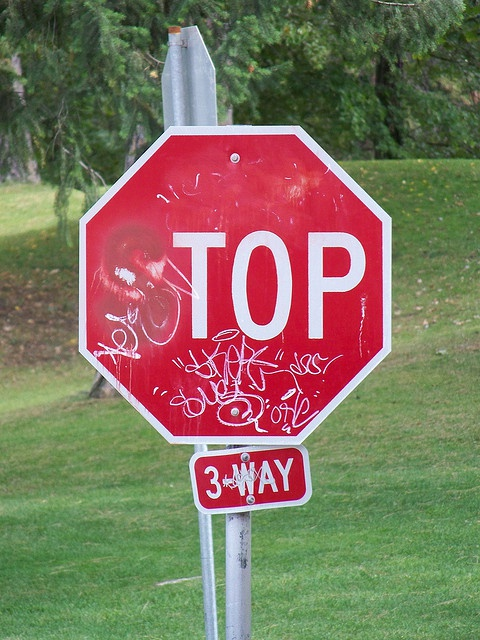Describe the objects in this image and their specific colors. I can see a stop sign in black, brown, and lavender tones in this image. 